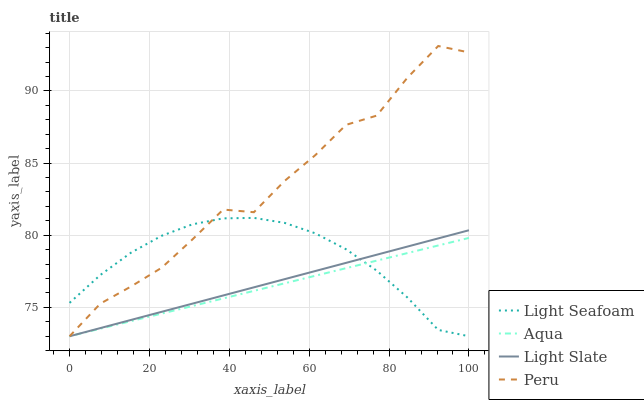Does Aqua have the minimum area under the curve?
Answer yes or no. Yes. Does Peru have the maximum area under the curve?
Answer yes or no. Yes. Does Light Seafoam have the minimum area under the curve?
Answer yes or no. No. Does Light Seafoam have the maximum area under the curve?
Answer yes or no. No. Is Aqua the smoothest?
Answer yes or no. Yes. Is Peru the roughest?
Answer yes or no. Yes. Is Light Seafoam the smoothest?
Answer yes or no. No. Is Light Seafoam the roughest?
Answer yes or no. No. Does Light Slate have the lowest value?
Answer yes or no. Yes. Does Peru have the highest value?
Answer yes or no. Yes. Does Light Seafoam have the highest value?
Answer yes or no. No. Does Aqua intersect Light Slate?
Answer yes or no. Yes. Is Aqua less than Light Slate?
Answer yes or no. No. Is Aqua greater than Light Slate?
Answer yes or no. No. 